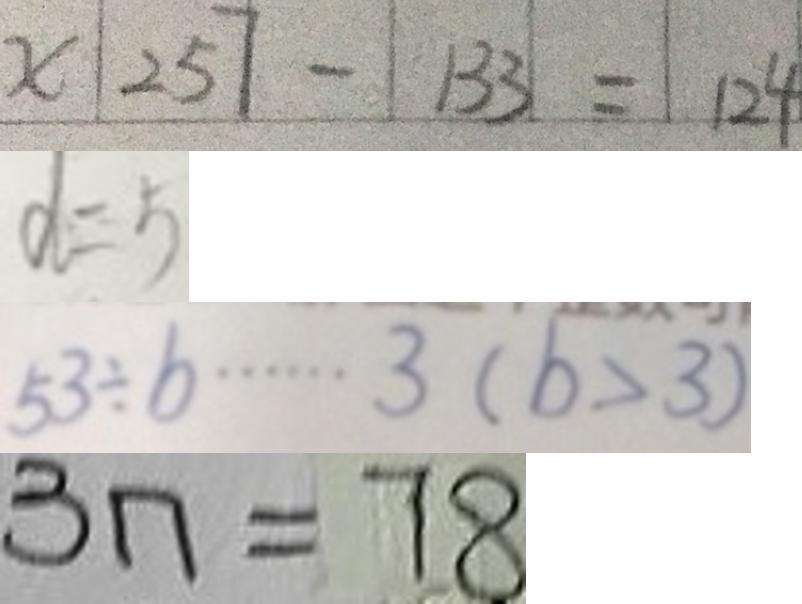<formula> <loc_0><loc_0><loc_500><loc_500>x 2 5 7 - 1 3 3 = 1 2 4 
 d = 5 
 5 3 \div b \cdots 3 ( b > 3 ) 
 3 n = 7 8</formula> 